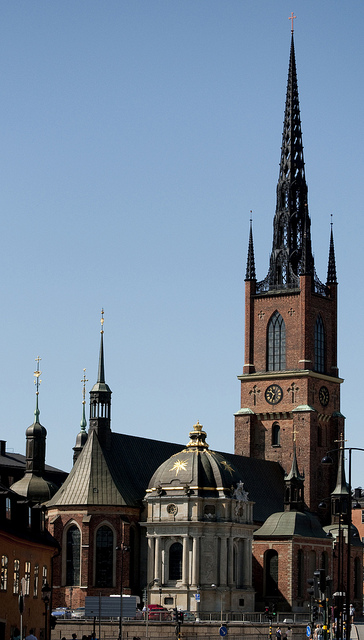<image>What famous landmark is shown? It is not sure which famous landmark is shown, it might be a cathedral, church, Downton Abbey, Big Ben, or the Tower of London. Is the very noticeable structure centered in the image analog or digital? I am not sure whether the very noticeable structure centered in the image is analog or digital. It could be analog or digital. Is the very noticeable structure centered in the image analog or digital? I don't know if the very noticeable structure in the image is centered, analog or digital. What famous landmark is shown? It is ambiguous what famous landmark is shown. It can be a cathedral, church, church tower, or Downton Abbey. 